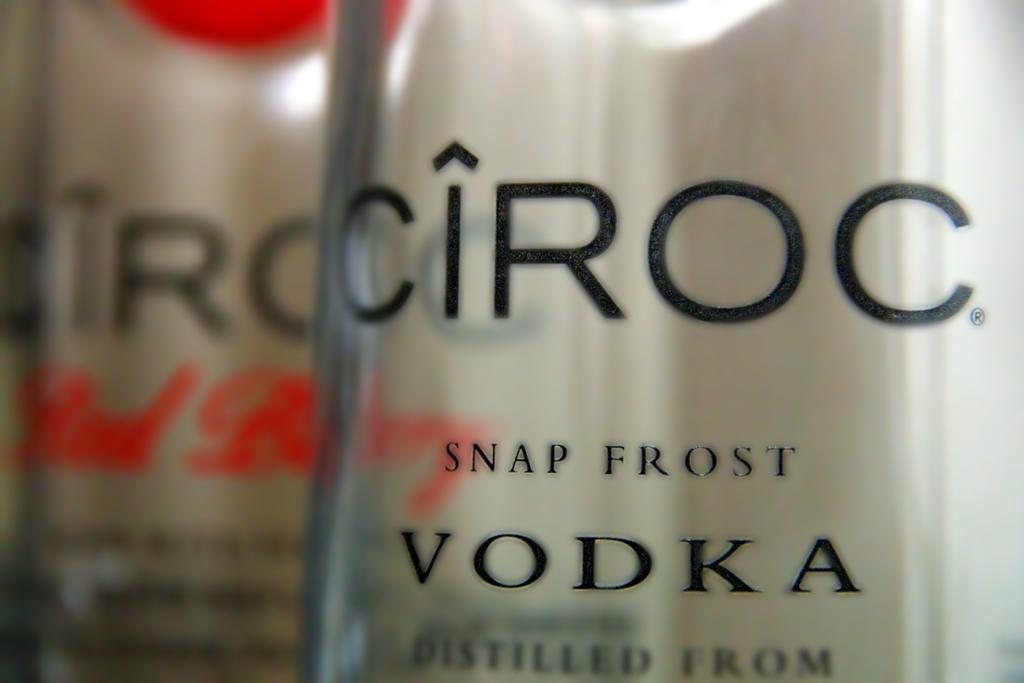What objects are present in the image? There are bottles in the image. What can be found on the bottles? The bottles have text on them. What type of jar is used to store the facts in the image? There is no jar present in the image, and the facts are not stored in a jar. 